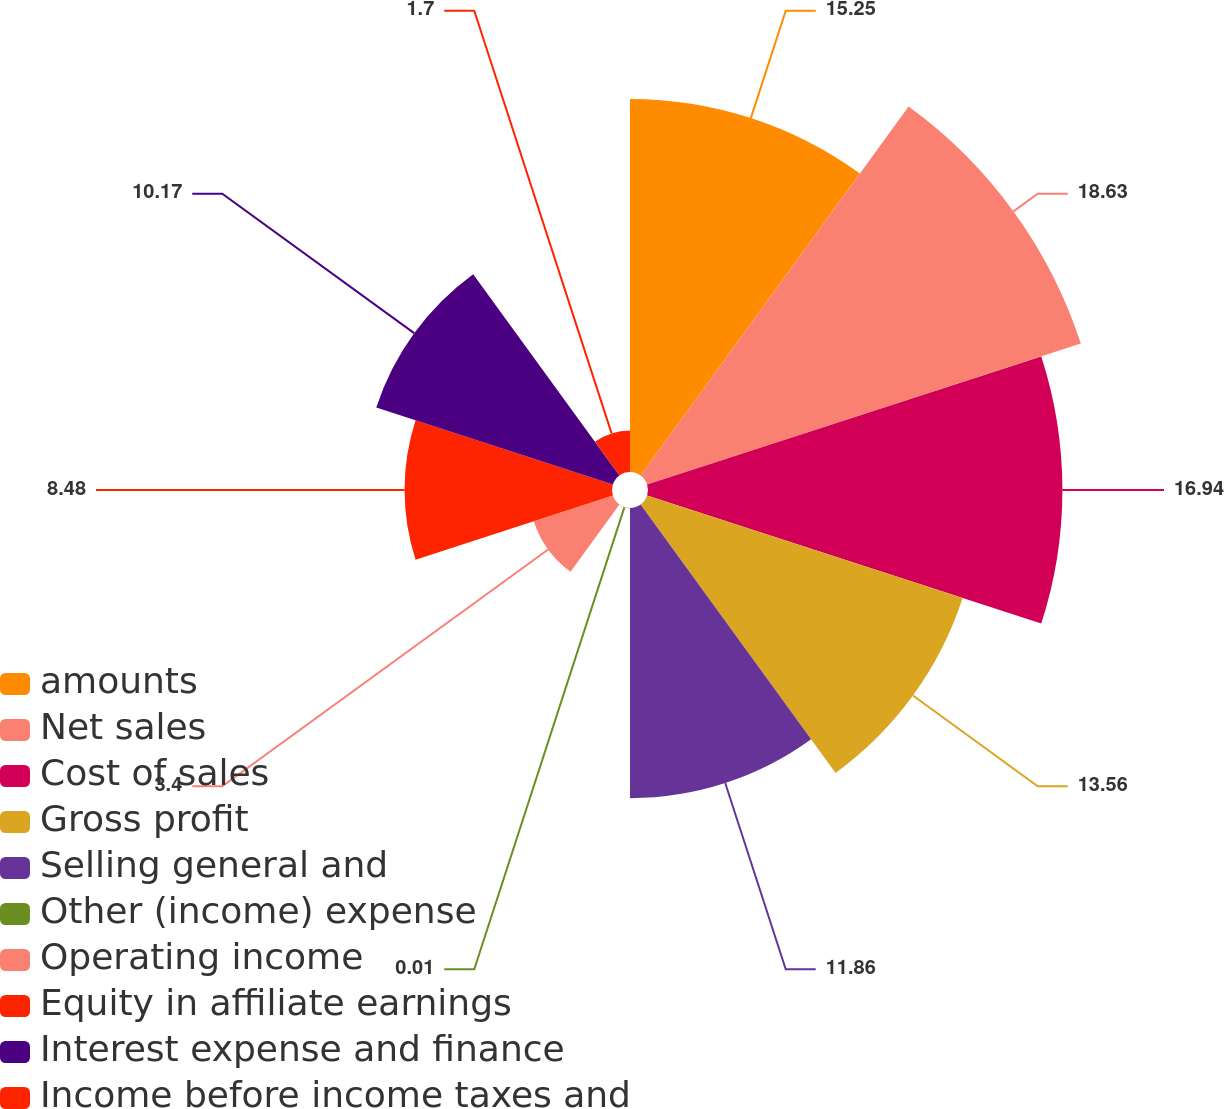Convert chart. <chart><loc_0><loc_0><loc_500><loc_500><pie_chart><fcel>amounts<fcel>Net sales<fcel>Cost of sales<fcel>Gross profit<fcel>Selling general and<fcel>Other (income) expense<fcel>Operating income<fcel>Equity in affiliate earnings<fcel>Interest expense and finance<fcel>Income before income taxes and<nl><fcel>15.25%<fcel>18.64%<fcel>16.94%<fcel>13.56%<fcel>11.86%<fcel>0.01%<fcel>3.4%<fcel>8.48%<fcel>10.17%<fcel>1.7%<nl></chart> 